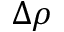<formula> <loc_0><loc_0><loc_500><loc_500>\Delta \rho</formula> 